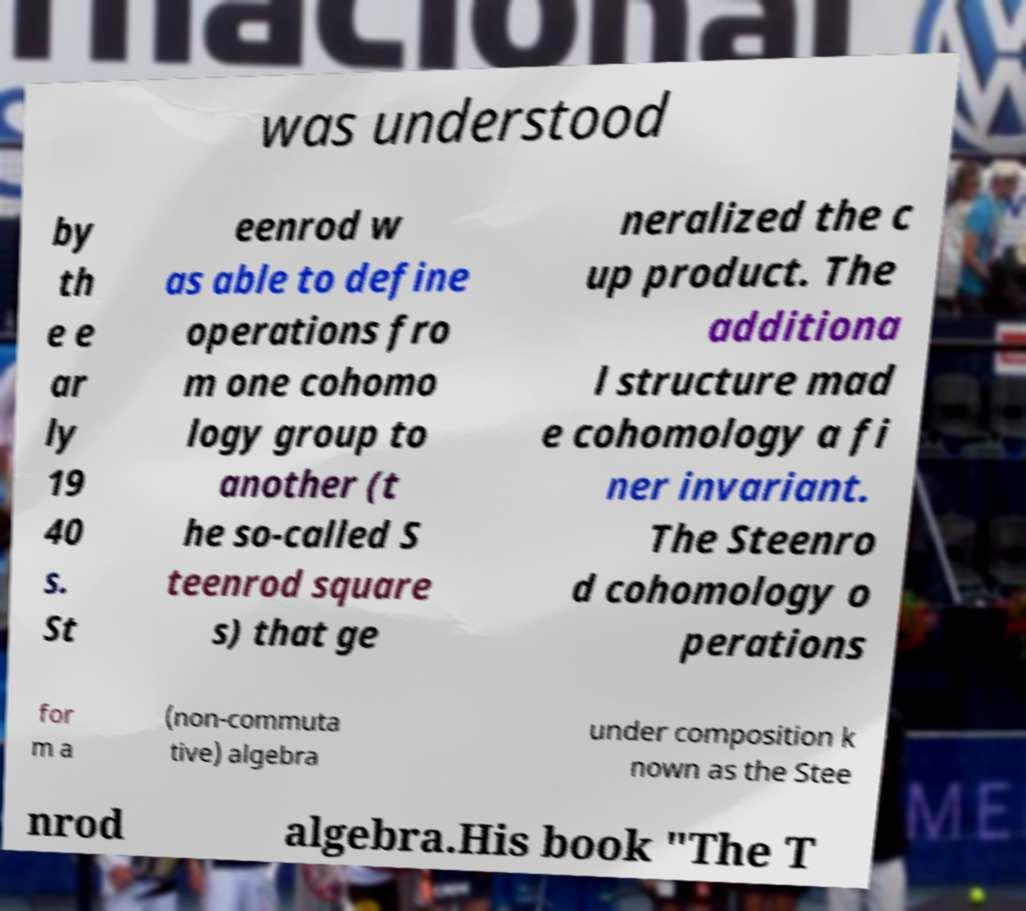Please identify and transcribe the text found in this image. was understood by th e e ar ly 19 40 s. St eenrod w as able to define operations fro m one cohomo logy group to another (t he so-called S teenrod square s) that ge neralized the c up product. The additiona l structure mad e cohomology a fi ner invariant. The Steenro d cohomology o perations for m a (non-commuta tive) algebra under composition k nown as the Stee nrod algebra.His book "The T 